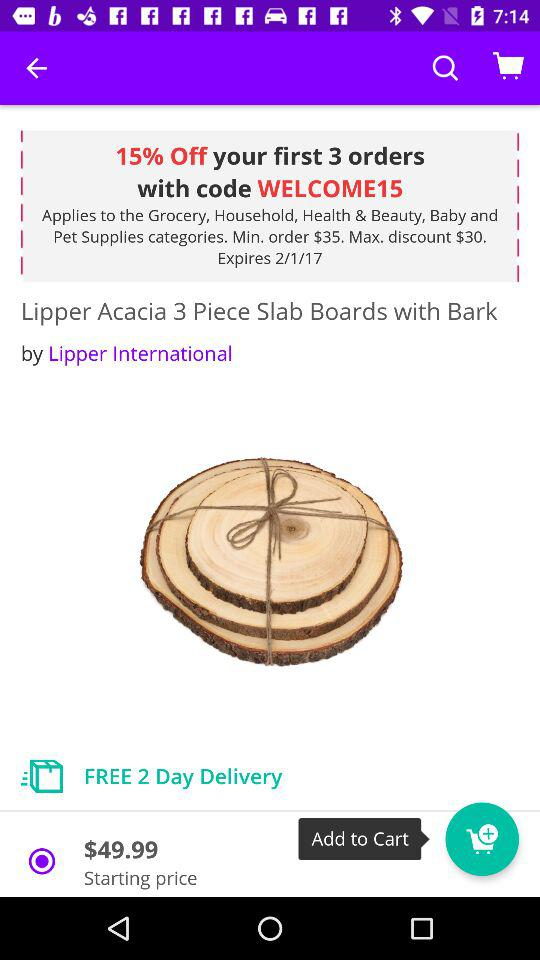What is the maximum discount? The maximum discount is $30. 